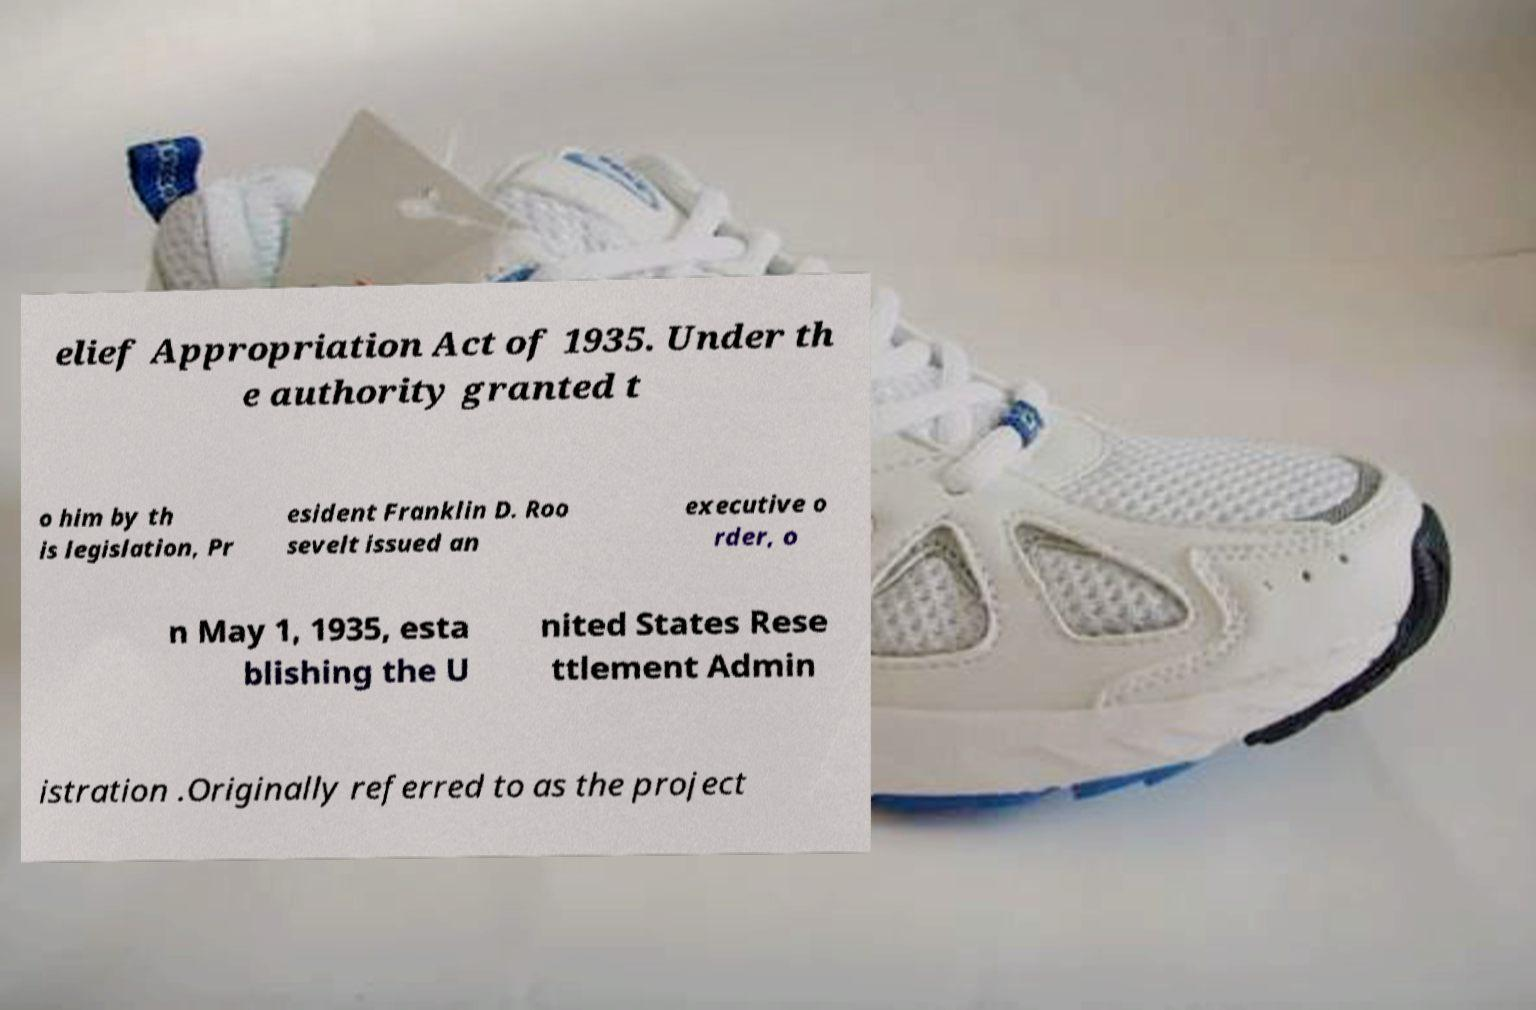I need the written content from this picture converted into text. Can you do that? elief Appropriation Act of 1935. Under th e authority granted t o him by th is legislation, Pr esident Franklin D. Roo sevelt issued an executive o rder, o n May 1, 1935, esta blishing the U nited States Rese ttlement Admin istration .Originally referred to as the project 